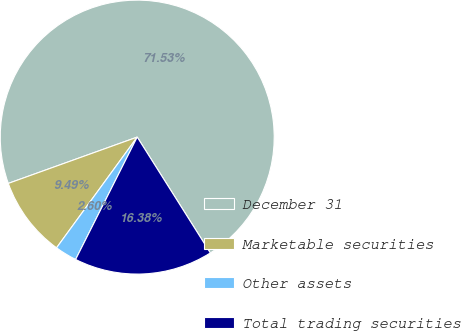Convert chart to OTSL. <chart><loc_0><loc_0><loc_500><loc_500><pie_chart><fcel>December 31<fcel>Marketable securities<fcel>Other assets<fcel>Total trading securities<nl><fcel>71.53%<fcel>9.49%<fcel>2.6%<fcel>16.38%<nl></chart> 